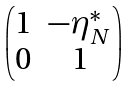Convert formula to latex. <formula><loc_0><loc_0><loc_500><loc_500>\begin{pmatrix} 1 & - \eta _ { N } ^ { * } \\ 0 & 1 \\ \end{pmatrix}</formula> 